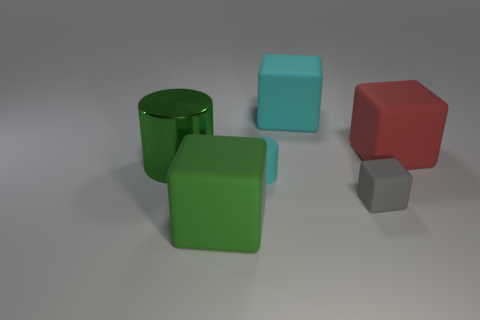Add 2 purple shiny blocks. How many objects exist? 8 Subtract all cubes. How many objects are left? 2 Subtract all big purple matte spheres. Subtract all large cyan objects. How many objects are left? 5 Add 2 big red objects. How many big red objects are left? 3 Add 6 cyan objects. How many cyan objects exist? 8 Subtract 0 blue cubes. How many objects are left? 6 